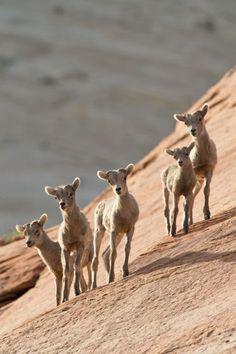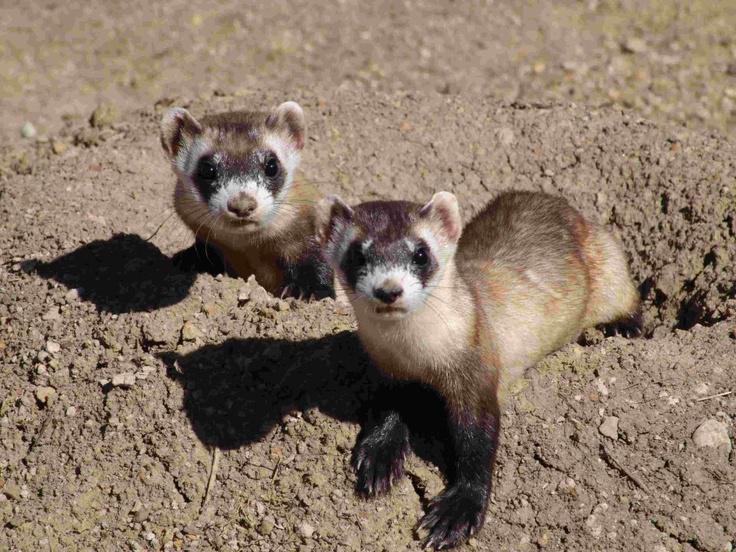The first image is the image on the left, the second image is the image on the right. Evaluate the accuracy of this statement regarding the images: "The right image contains exactly two ferrets.". Is it true? Answer yes or no. Yes. 